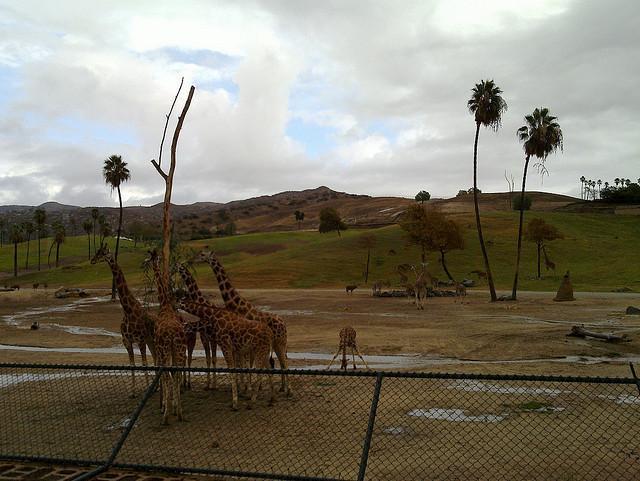How many giraffes can you see?
Give a very brief answer. 4. 